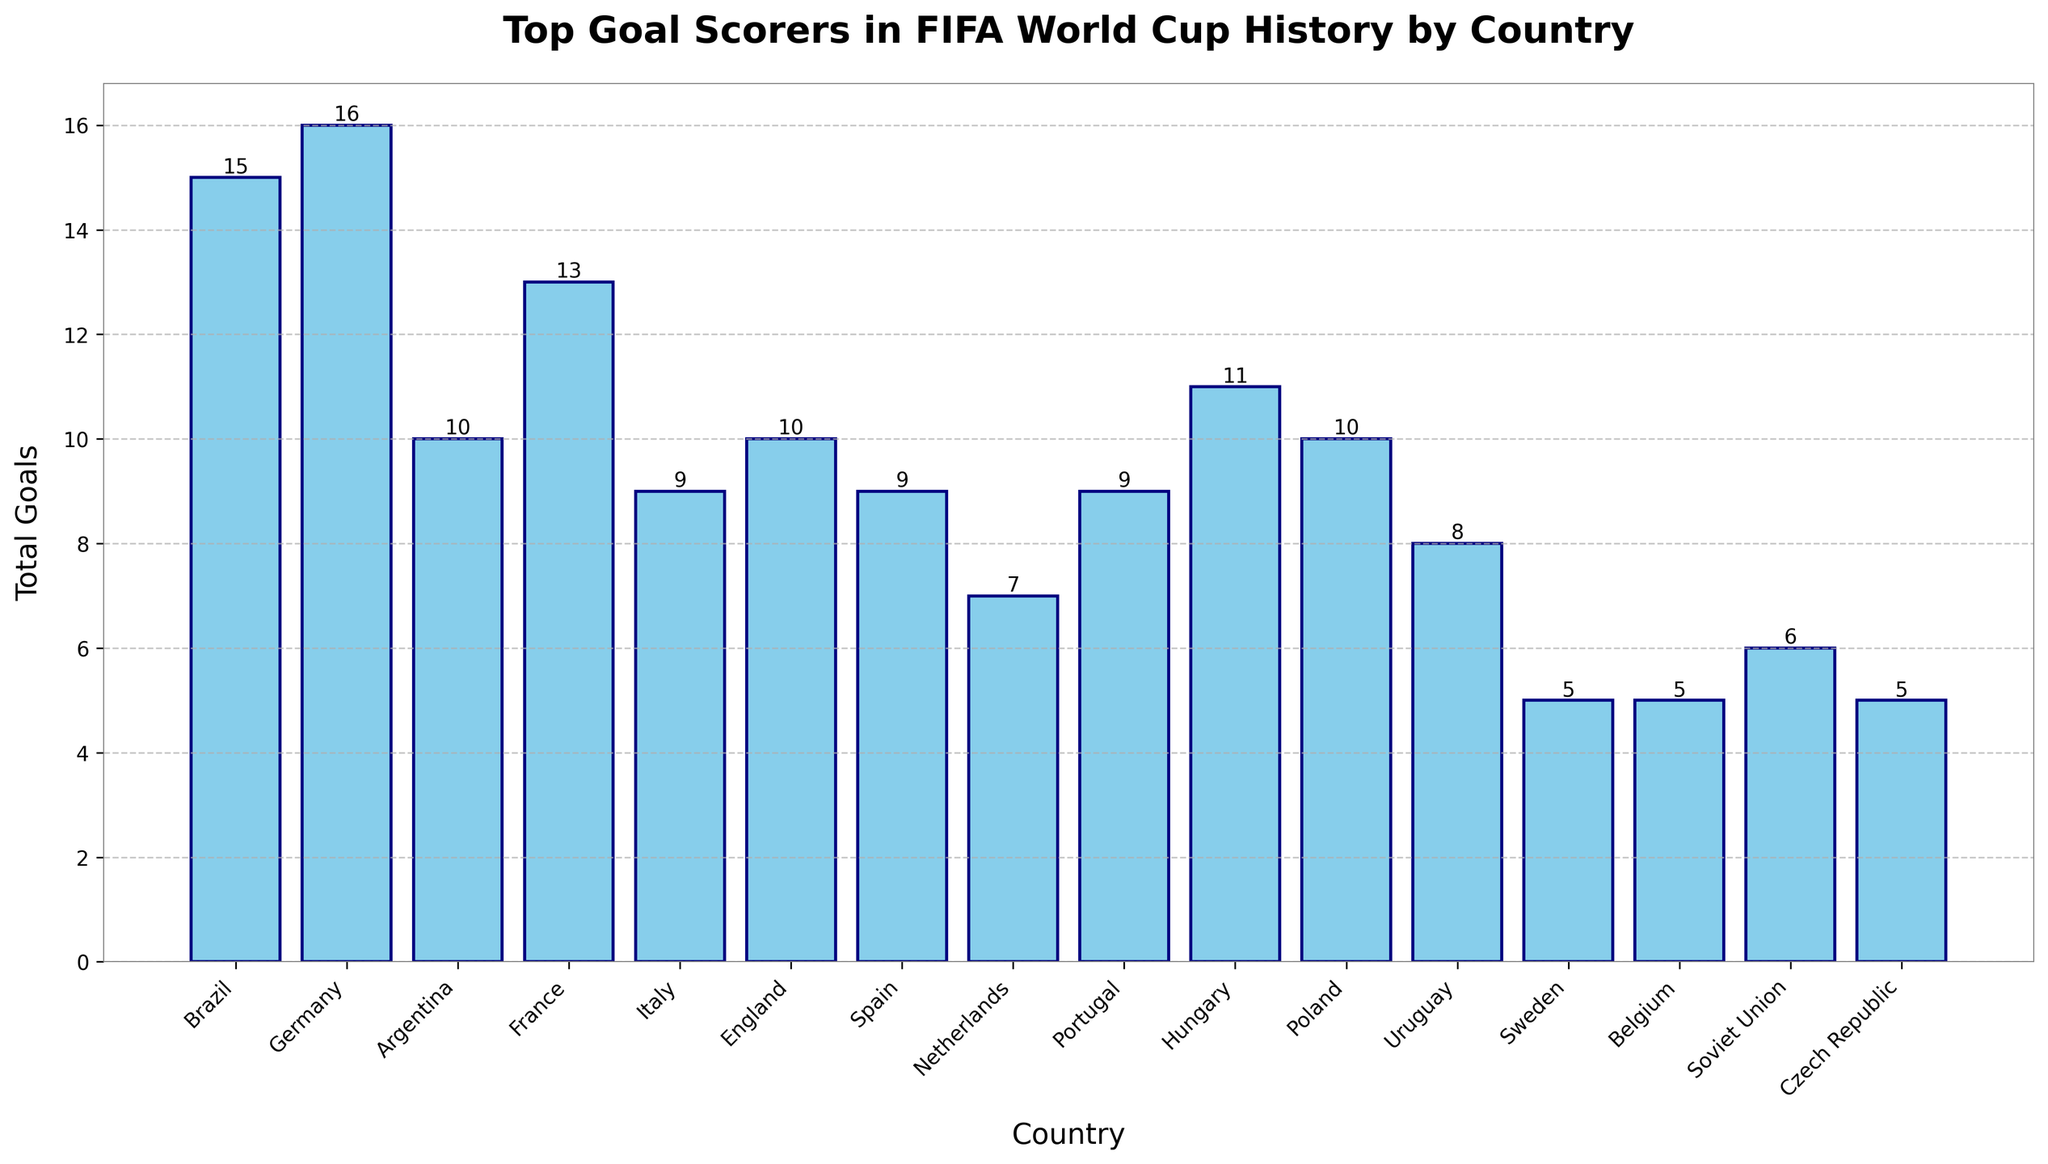What country has the top goal scorer with the most goals? By observing the bar lengths in the figure, Germany has the longest bar with Miroslav Klose scoring 16 goals.
Answer: Germany How many goals have been scored by the top goal scorers of Brazil and Argentina combined? Sum the goals scored by Ronaldo from Brazil (15) and Gabriel Batistuta from Argentina (10), which gives 15 + 10 = 25.
Answer: 25 Which country’s top goal scorer has fewer goals: Spain or Italy? Compare the bar lengths for Spain and Italy; both David Villa (Spain) and Paolo Rossi (Italy) scored 9 goals. Therefore, neither has fewer goals.
Answer: Neither What is the difference in total goals scored between Miroslav Klose from Germany and Just Fontaine from France? Subtract Just Fontaine’s goals (13) from Miroslav Klose’s goals (16), which is 16 - 13 = 3.
Answer: 3 Of the countries shown, which top goal scorer has the least number of goals, and how many goals did they score? Identify the shortest bar in the figure, which belongs to Marc Wilmots from Belgium and Tomáš Skuhravý from Czech Republic, both scoring 5 goals.
Answer: Belgium and Czech Republic, 5 What is the average number of goals scored by the top goal scorers from Hungary, Poland, and Portugal? Sum the goals scored by top scorers of Hungary (11), Poland (10), and Portugal (9), then divide by 3, which is (11 + 10 + 9) / 3 = 30 / 3 = 10.
Answer: 10 Is there a country’s top goal scorer who scored exactly 6 goals? Observe the bars for a height of 6. Only Oleg Salenko from the Soviet Union has exactly 6 goals.
Answer: Yes, Soviet Union How many more goals did Ronaldo from Brazil score compared to Óscar Míguez from Uruguay? Subtract Óscar Míguez's goals (8) from Ronaldo's goals (15), which is 15 - 8 = 7.
Answer: 7 Which two countries’ top goal scorers have scored the same number of goals, and what is the number of goals? Observing the bars, Gary Lineker from England and Gabriel Batistuta from Argentina both have 10 goals.
Answer: England and Argentina, 10 Are there more countries with top goal scorers who have fewer than 10 goals, or who have 10 or more goals? Count the number of countries with top scorers who have fewer than 10 goals (8 countries: Netherlands, Uruguay, Soviet Union, Sweden, Belgium, Czech Republic, Italy, and Spain) and compare to those with 10 or more (8 countries: Germany, Brazil, France, Argentina, England, Hungary, Poland, Portugal). The counts are equal (8 each).
Answer: Equal 